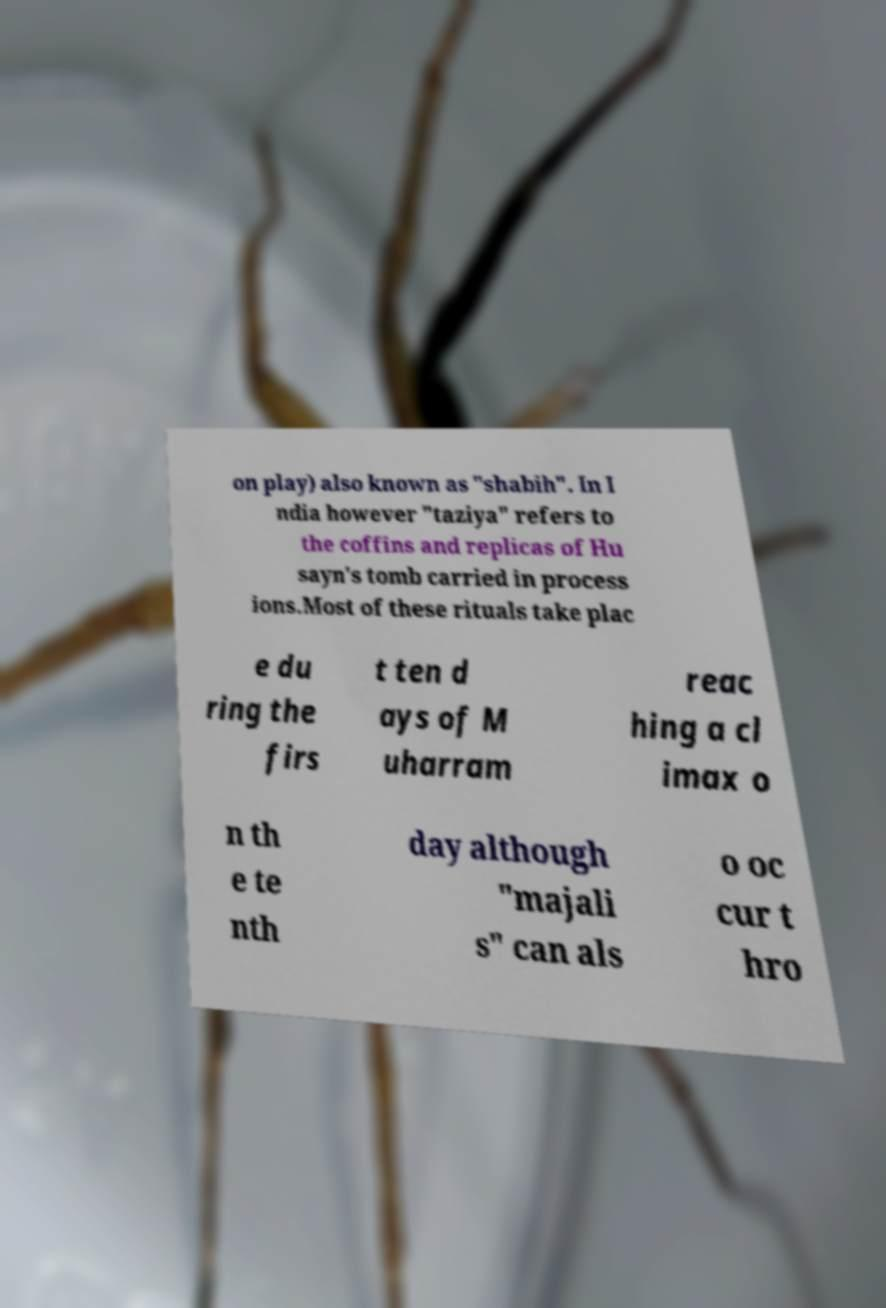Please identify and transcribe the text found in this image. on play) also known as "shabih". In I ndia however "taziya" refers to the coffins and replicas of Hu sayn's tomb carried in process ions.Most of these rituals take plac e du ring the firs t ten d ays of M uharram reac hing a cl imax o n th e te nth day although "majali s" can als o oc cur t hro 